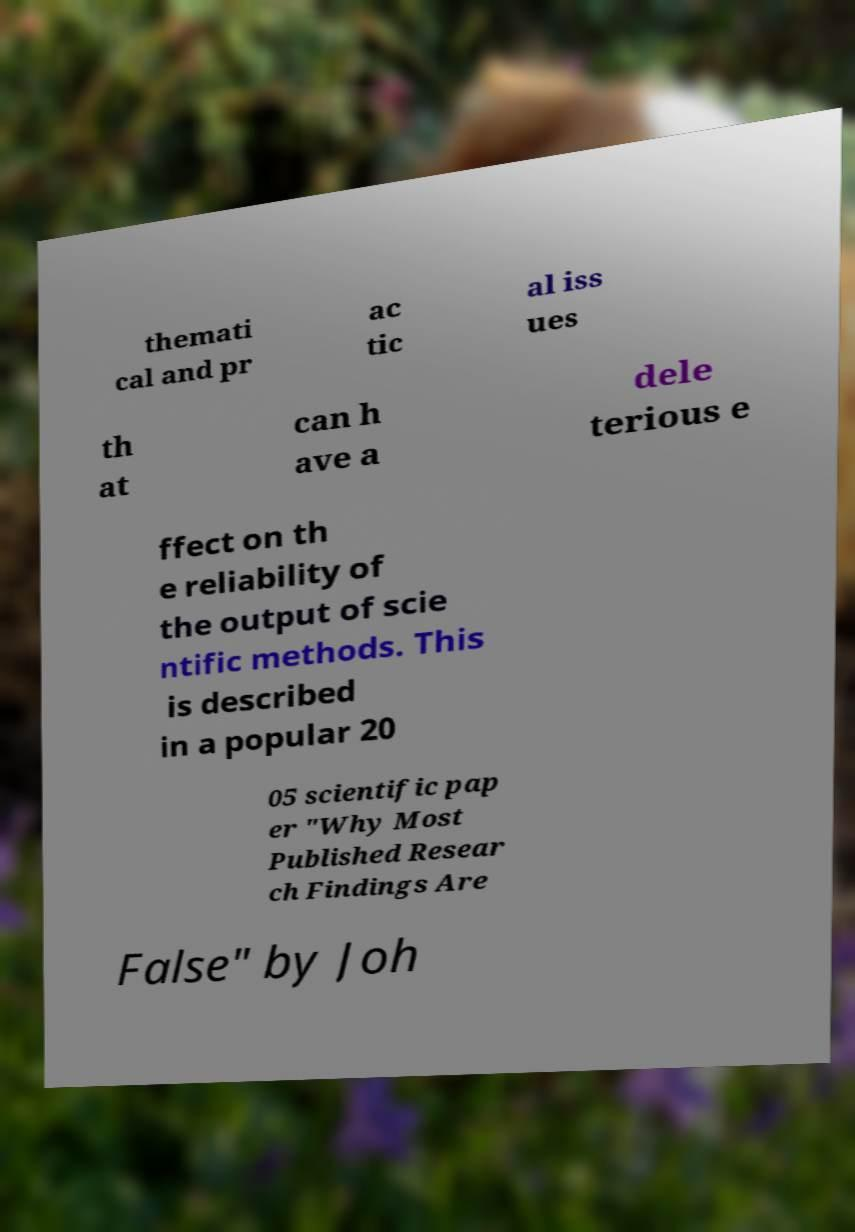There's text embedded in this image that I need extracted. Can you transcribe it verbatim? themati cal and pr ac tic al iss ues th at can h ave a dele terious e ffect on th e reliability of the output of scie ntific methods. This is described in a popular 20 05 scientific pap er "Why Most Published Resear ch Findings Are False" by Joh 